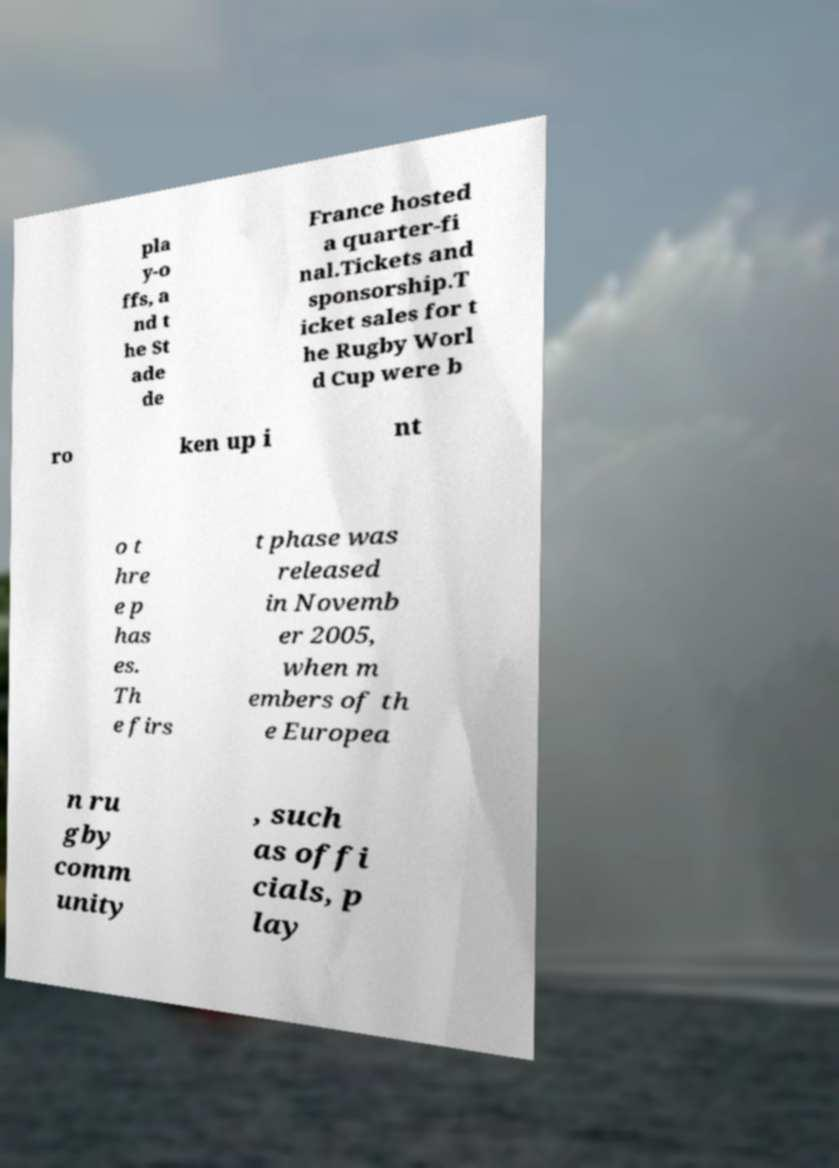Please read and relay the text visible in this image. What does it say? pla y-o ffs, a nd t he St ade de France hosted a quarter-fi nal.Tickets and sponsorship.T icket sales for t he Rugby Worl d Cup were b ro ken up i nt o t hre e p has es. Th e firs t phase was released in Novemb er 2005, when m embers of th e Europea n ru gby comm unity , such as offi cials, p lay 